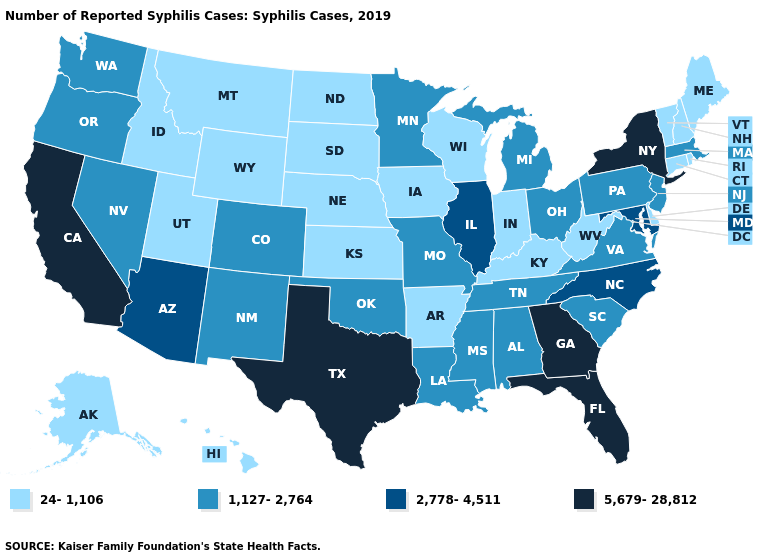Name the states that have a value in the range 24-1,106?
Quick response, please. Alaska, Arkansas, Connecticut, Delaware, Hawaii, Idaho, Indiana, Iowa, Kansas, Kentucky, Maine, Montana, Nebraska, New Hampshire, North Dakota, Rhode Island, South Dakota, Utah, Vermont, West Virginia, Wisconsin, Wyoming. Name the states that have a value in the range 24-1,106?
Keep it brief. Alaska, Arkansas, Connecticut, Delaware, Hawaii, Idaho, Indiana, Iowa, Kansas, Kentucky, Maine, Montana, Nebraska, New Hampshire, North Dakota, Rhode Island, South Dakota, Utah, Vermont, West Virginia, Wisconsin, Wyoming. Name the states that have a value in the range 1,127-2,764?
Short answer required. Alabama, Colorado, Louisiana, Massachusetts, Michigan, Minnesota, Mississippi, Missouri, Nevada, New Jersey, New Mexico, Ohio, Oklahoma, Oregon, Pennsylvania, South Carolina, Tennessee, Virginia, Washington. What is the value of Utah?
Give a very brief answer. 24-1,106. Name the states that have a value in the range 5,679-28,812?
Give a very brief answer. California, Florida, Georgia, New York, Texas. Among the states that border Texas , which have the highest value?
Quick response, please. Louisiana, New Mexico, Oklahoma. What is the highest value in states that border North Carolina?
Short answer required. 5,679-28,812. Does the first symbol in the legend represent the smallest category?
Concise answer only. Yes. Which states have the lowest value in the South?
Be succinct. Arkansas, Delaware, Kentucky, West Virginia. Does Oklahoma have the lowest value in the USA?
Answer briefly. No. What is the value of Nevada?
Short answer required. 1,127-2,764. How many symbols are there in the legend?
Keep it brief. 4. What is the value of Hawaii?
Give a very brief answer. 24-1,106. How many symbols are there in the legend?
Keep it brief. 4. What is the value of Kentucky?
Write a very short answer. 24-1,106. 